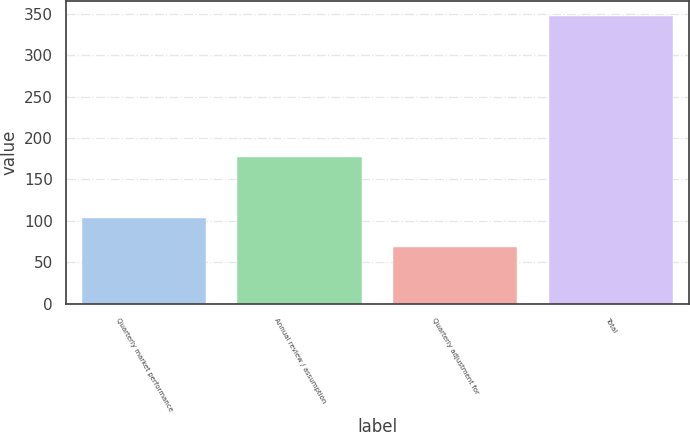Convert chart to OTSL. <chart><loc_0><loc_0><loc_500><loc_500><bar_chart><fcel>Quarterly market performance<fcel>Annual review / assumption<fcel>Quarterly adjustment for<fcel>Total<nl><fcel>103<fcel>177<fcel>68<fcel>348<nl></chart> 